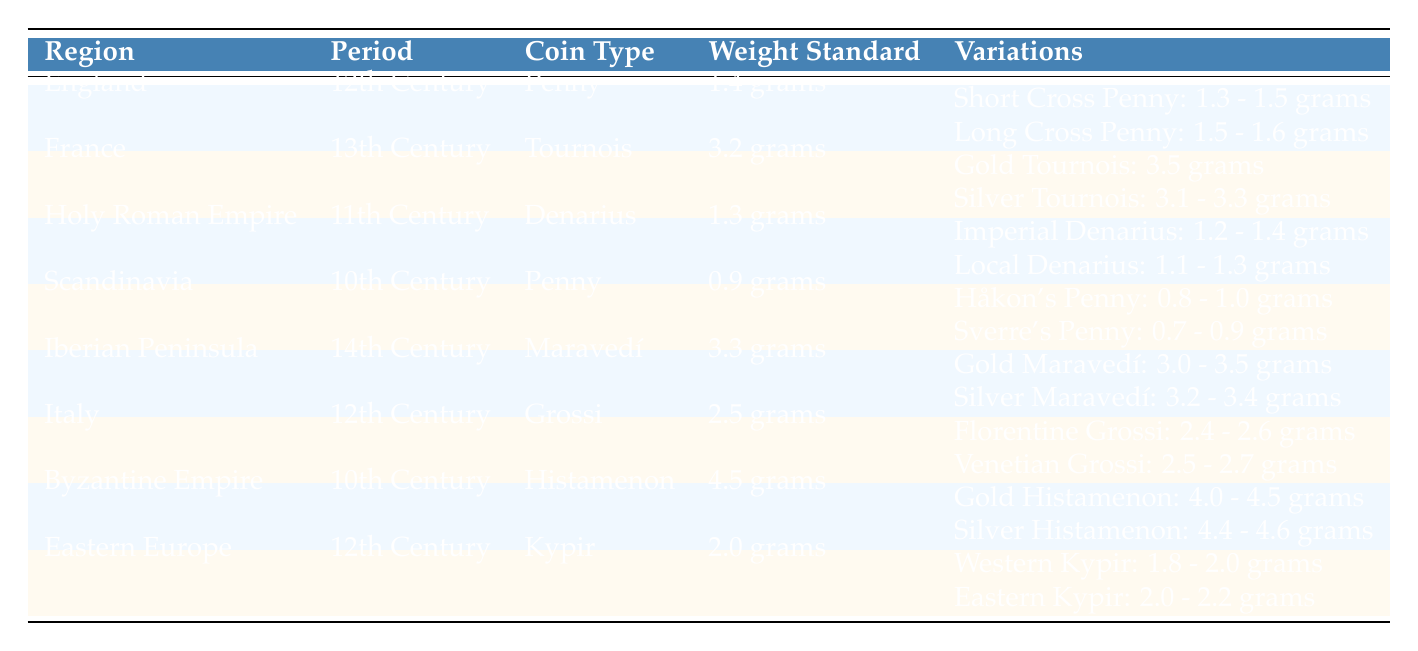What is the weight standard of the Penny in England during the 12th Century? The table shows that the weight standard for the Penny in England during the 12th Century is listed in the corresponding cell. Specifically, it states "1.4 grams" for the weight standard of the Penny.
Answer: 1.4 grams Which coin type from the Byzantine Empire has the highest weight standard? Referring to the table, the Histamenon from the Byzantine Empire is listed in the 10th Century with a weight standard of 4.5 grams, which is higher than any other coin type across the regions provided.
Answer: Histamenon What is the average weight range of the Gold Tournois from France in the 13th Century? The table states that the Gold Tournois has an average weight of "3.5 grams". There is only one value, so there is no need for a range. Thus, the average weight is simply stated.
Answer: 3.5 grams Are there any variations of the Penny from Scandinavia? Upon scanning the table, we see that the Penny from Scandinavia has two variations listed: Håkon's Penny and Sverre's Penny. Therefore, the statement is true; there are indeed variations.
Answer: Yes How does the average weight of the Short Cross Penny compare to the Long Cross Penny in England? The average weight of the Short Cross Penny is given as "1.3 - 1.5 grams" and the Long Cross Penny is "1.5 - 1.6 grams". The Long Cross Penny has a higher average weight in comparison to the Short Cross Penny. This can be confirmed by evaluating the ranges provided.
Answer: Long Cross Penny has a higher average weight What is the variational weight range for the Silver Maravedí from the Iberian Peninsula in the 14th Century? The table lists the Silver Maravedí with an average weight range of "3.2 - 3.4 grams." This specific information is directly referenced in the row related to the Iberian Peninsula's coinage.
Answer: 3.2 - 3.4 grams Which region has a weight standard of 0.9 grams? The table specifies that the region concerning a weight standard of 0.9 grams is Scandinavia, as indicated in the relevant row for the 10th Century.
Answer: Scandinavia What is the average weight for the Eastern Kypir as mentioned in the table? The table clearly indicates that the Eastern Kypir has an average weight of "2.0 - 2.2 grams." This information is found in the relevant section of the row pertaining to Eastern Europe in the 12th Century.
Answer: 2.0 - 2.2 grams What are the weight standards of the Grossi from Italy in the 12th Century? The weight standard for the Grossi from Italy is listed as "2.5 grams." Additionally, the variational weights for both Florentine and Venetian Grossi provide more context about variations but do not change the standard itself.
Answer: 2.5 grams 